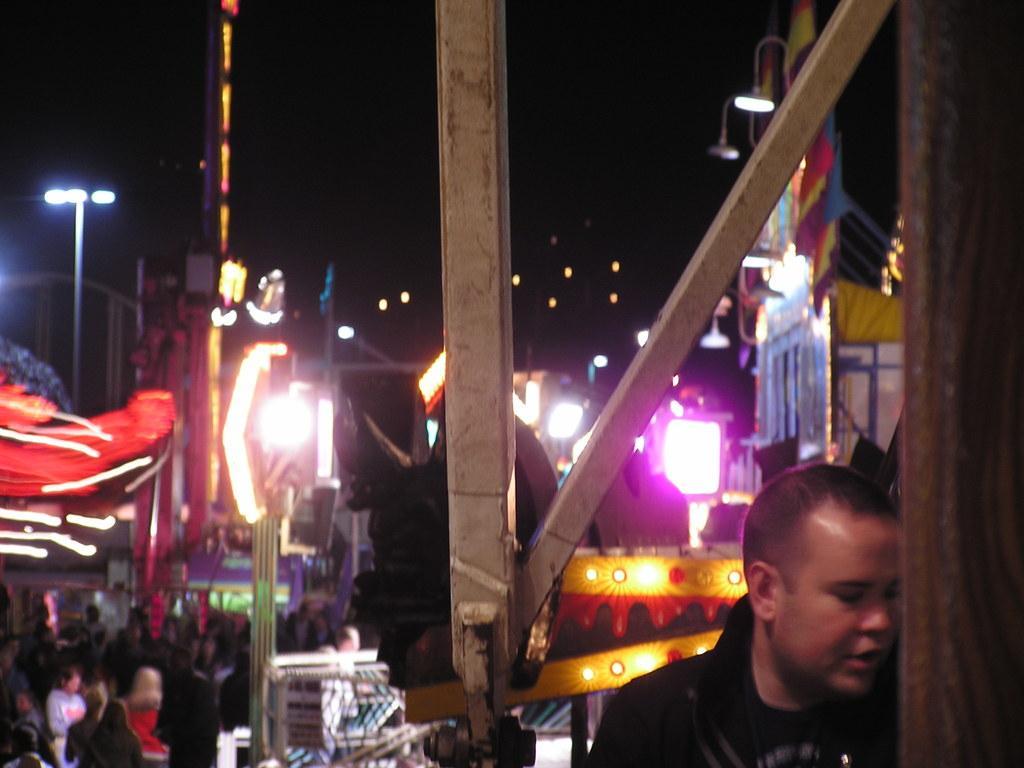In one or two sentences, can you explain what this image depicts? In this image I can see a person wearing black colored dress, few metal rods, few other persons standing, few lights and in the background I can see few poles, few buildings and the dark sky. 